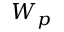Convert formula to latex. <formula><loc_0><loc_0><loc_500><loc_500>W _ { p }</formula> 